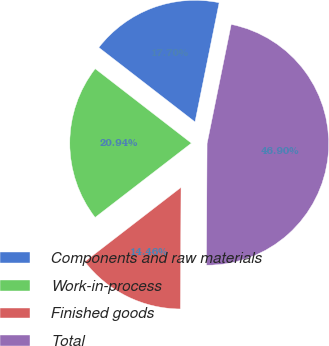Convert chart to OTSL. <chart><loc_0><loc_0><loc_500><loc_500><pie_chart><fcel>Components and raw materials<fcel>Work-in-process<fcel>Finished goods<fcel>Total<nl><fcel>17.7%<fcel>20.94%<fcel>14.46%<fcel>46.9%<nl></chart> 